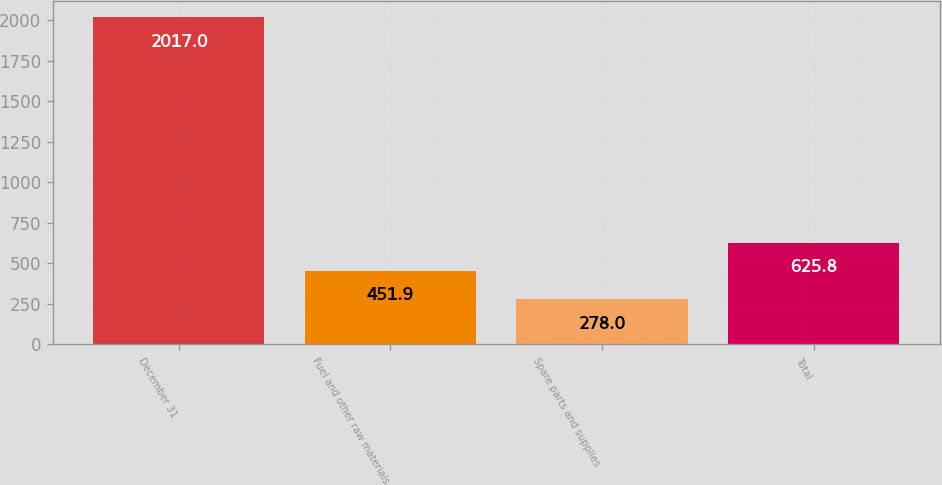<chart> <loc_0><loc_0><loc_500><loc_500><bar_chart><fcel>December 31<fcel>Fuel and other raw materials<fcel>Spare parts and supplies<fcel>Total<nl><fcel>2017<fcel>451.9<fcel>278<fcel>625.8<nl></chart> 